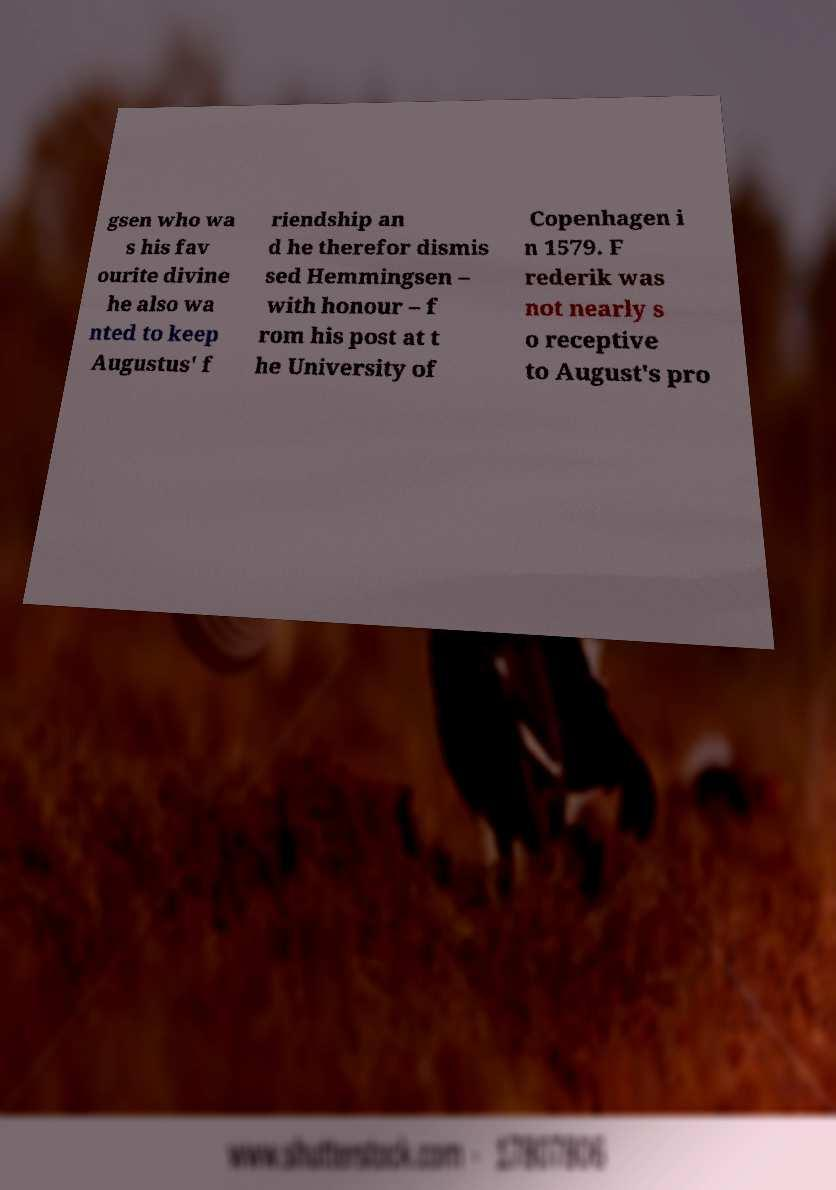What messages or text are displayed in this image? I need them in a readable, typed format. gsen who wa s his fav ourite divine he also wa nted to keep Augustus' f riendship an d he therefor dismis sed Hemmingsen – with honour – f rom his post at t he University of Copenhagen i n 1579. F rederik was not nearly s o receptive to August's pro 